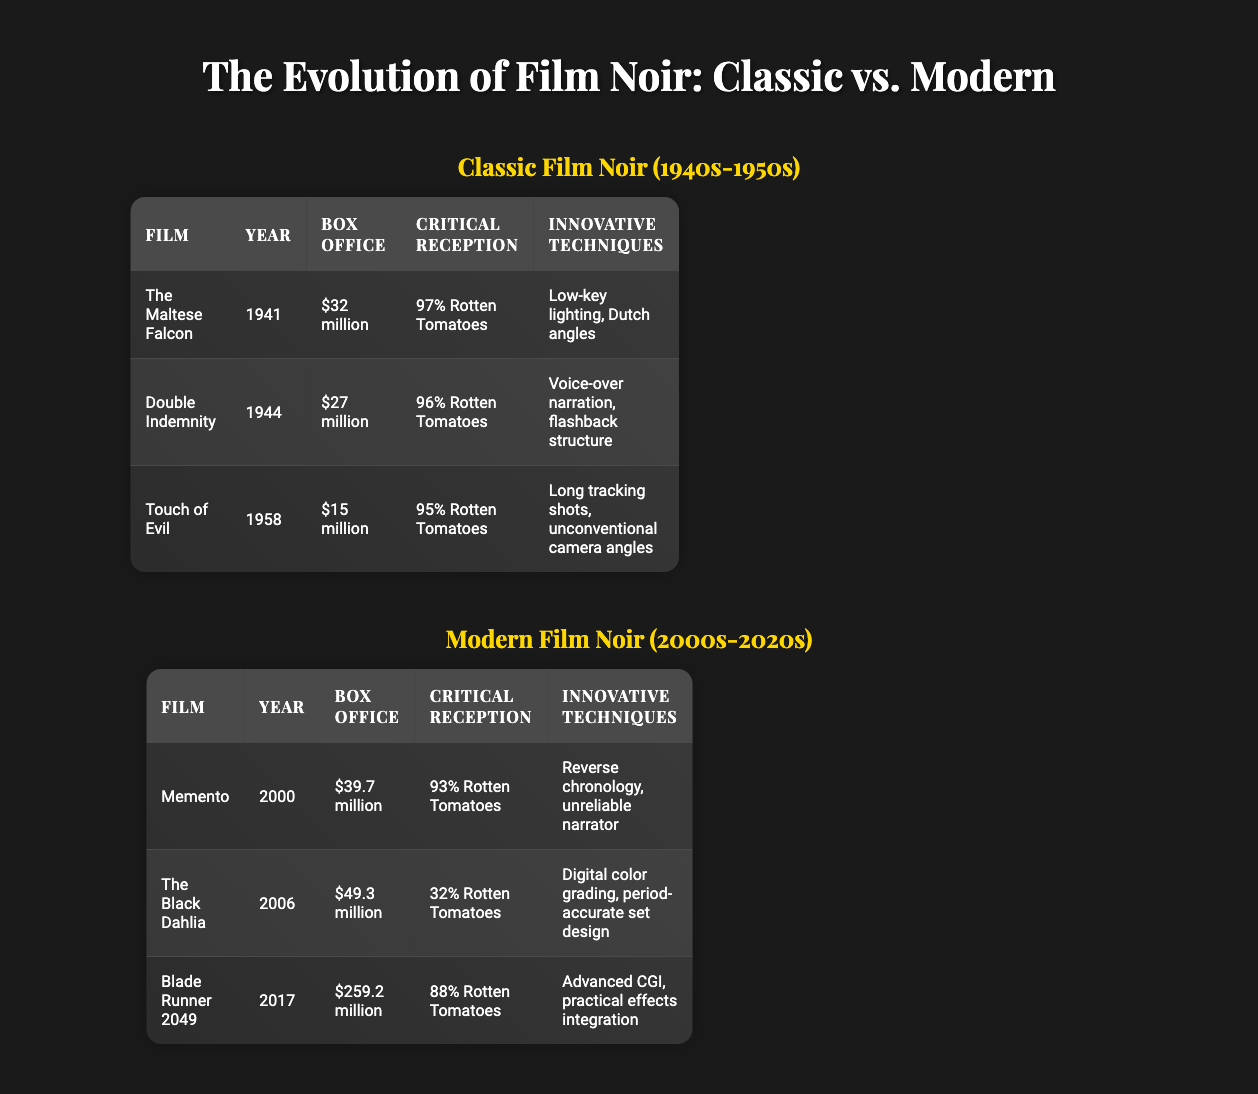What is the box office revenue of "Blade Runner 2049"? The box office revenue for "Blade Runner 2049" is listed under the Modern Film Noir section, where it states "$259.2 million."
Answer: $259.2 million Which classic film noir has the highest critical reception? By checking the Critical Reception column for classic film noir films, "The Maltese Falcon" has the highest rating at 97% Rotten Tomatoes.
Answer: The Maltese Falcon What is the average box office of the classic film noir films? The box offices for classic films are $32 million, $27 million, and $15 million. To find the average, sum these values (32 + 27 + 15 = 74), then divide by the number of films (3). Thus, the average is 74/3 = approximately 24.7 million.
Answer: $24.7 million Is "The Black Dahlia" more critically acclaimed than "Touch of Evil"? "The Black Dahlia" has a critical reception of 32% Rotten Tomatoes, while "Touch of Evil" has 95% Rotten Tomatoes. Since 32% is less than 95%, it is false to say that "The Black Dahlia" is more critically acclaimed.
Answer: No Which modern film noir film has the lowest box office revenue? By comparing the box office revenues listed for modern film noirs, "Memento" ($39.7 million), "The Black Dahlia" ($49.3 million), and "Blade Runner 2049" ($259.2 million), "Memento" has the lowest box office revenue of the three.
Answer: Memento What innovative techniques differentiate "Double Indemnity" and "The Black Dahlia"? "Double Indemnity" uses voice-over narration and flashback structure, whereas "The Black Dahlia" features digital color grading and period-accurate set design. These differing innovative techniques highlight the distinct approaches of each film.
Answer: Voice-over narration, flashback structure and digital color grading, period-accurate set design What is the difference in box office revenue between the highest-grossing classic film noir and the highest-grossing modern film noir? The highest-grossing classic film noir is "The Maltese Falcon" at $32 million. The highest-grossing modern film noir is "Blade Runner 2049" at $259.2 million. Subtracting the classic revenue from the modern gives us $259.2 million - $32 million = $227.2 million.
Answer: $227.2 million How many films in total are listed under the modern film noir category? The Modern Film Noir section lists three films: "Memento," "The Black Dahlia," and "Blade Runner 2049." Therefore, the total count of films is 3.
Answer: 3 